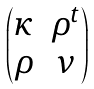<formula> <loc_0><loc_0><loc_500><loc_500>\begin{pmatrix} \kappa & \rho ^ { t } \\ \rho & \nu \end{pmatrix}</formula> 